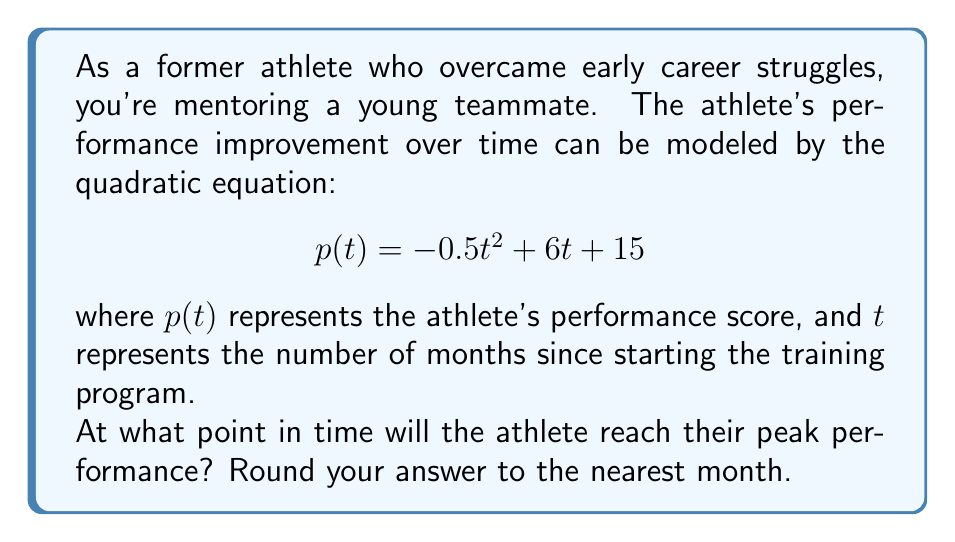Provide a solution to this math problem. To find the peak performance, we need to determine the vertex of the quadratic function. For a quadratic function in the form $f(x) = ax^2 + bx + c$, the x-coordinate of the vertex is given by $x = -\frac{b}{2a}$.

In our equation $p(t) = -0.5t^2 + 6t + 15$:
$a = -0.5$
$b = 6$
$c = 15$

Let's calculate the t-coordinate of the vertex:

$$t = -\frac{b}{2a} = -\frac{6}{2(-0.5)} = -\frac{6}{-1} = 6$$

To verify this is a maximum (peak) and not a minimum:
The coefficient of $t^2$ is negative ($-0.5$), confirming this is indeed a maximum point.

Therefore, the athlete will reach their peak performance at $t = 6$ months.

Rounding to the nearest month isn't necessary in this case as the result is already a whole number.
Answer: The athlete will reach their peak performance at 6 months. 